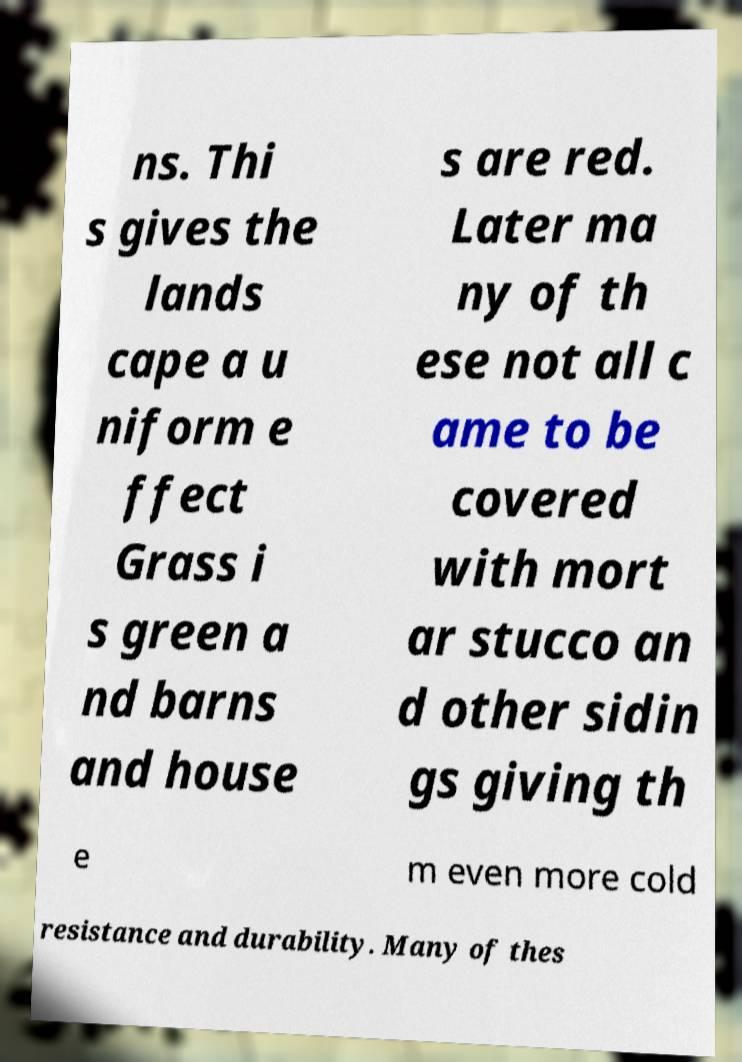Can you accurately transcribe the text from the provided image for me? ns. Thi s gives the lands cape a u niform e ffect Grass i s green a nd barns and house s are red. Later ma ny of th ese not all c ame to be covered with mort ar stucco an d other sidin gs giving th e m even more cold resistance and durability. Many of thes 